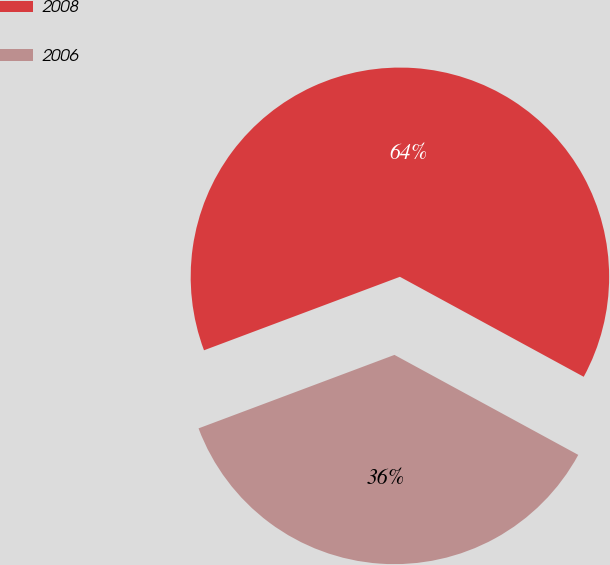Convert chart. <chart><loc_0><loc_0><loc_500><loc_500><pie_chart><fcel>2008<fcel>2006<nl><fcel>63.64%<fcel>36.36%<nl></chart> 